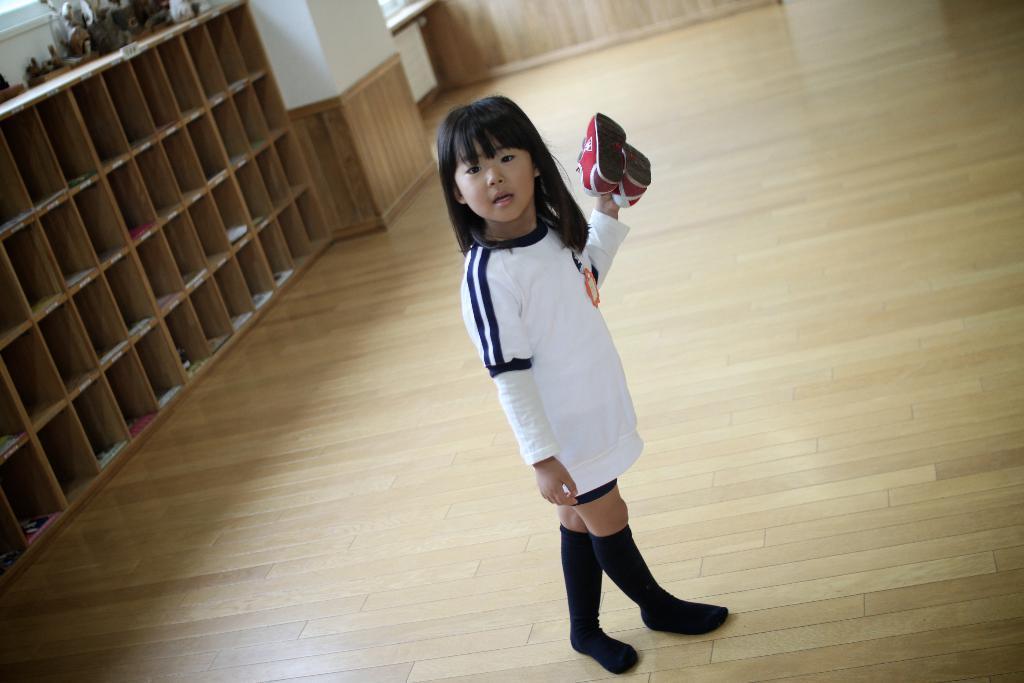Please provide a concise description of this image. In this picture we can see a girl holding shoes in her hand and standing on the path. There is a wooden rack and a pillar on the left side. 